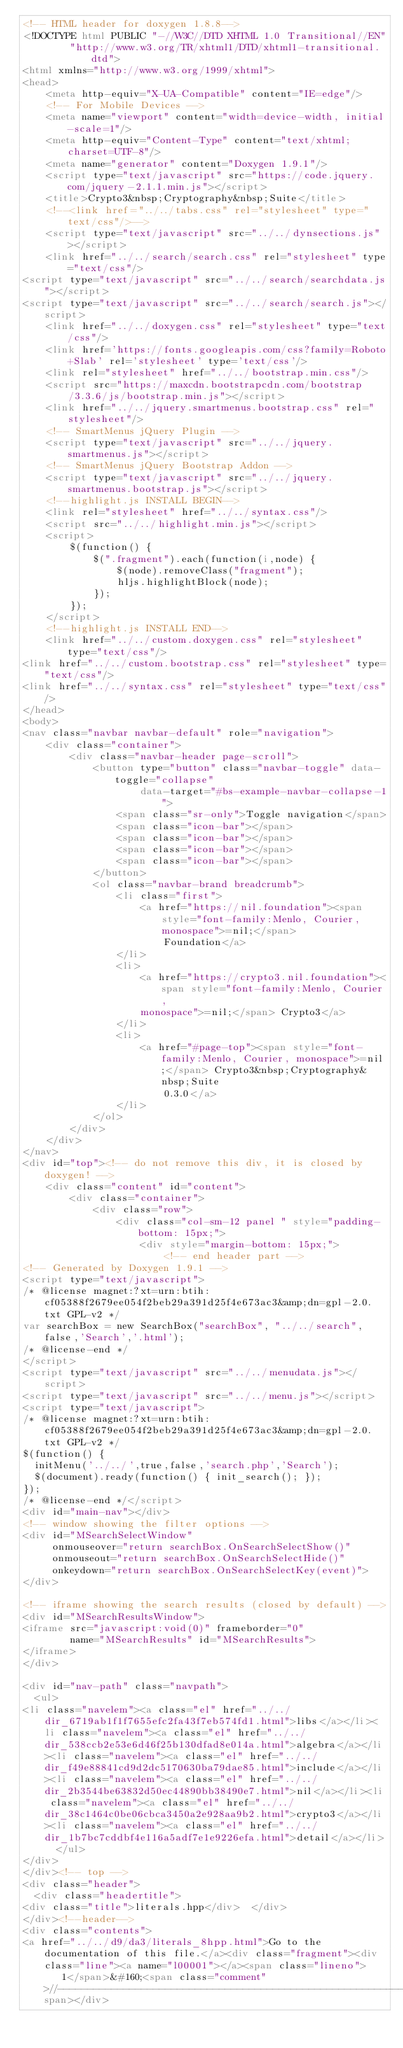Convert code to text. <code><loc_0><loc_0><loc_500><loc_500><_HTML_><!-- HTML header for doxygen 1.8.8-->
<!DOCTYPE html PUBLIC "-//W3C//DTD XHTML 1.0 Transitional//EN"
        "http://www.w3.org/TR/xhtml1/DTD/xhtml1-transitional.dtd">
<html xmlns="http://www.w3.org/1999/xhtml">
<head>
    <meta http-equiv="X-UA-Compatible" content="IE=edge"/>
    <!-- For Mobile Devices -->
    <meta name="viewport" content="width=device-width, initial-scale=1"/>
    <meta http-equiv="Content-Type" content="text/xhtml;charset=UTF-8"/>
    <meta name="generator" content="Doxygen 1.9.1"/>
    <script type="text/javascript" src="https://code.jquery.com/jquery-2.1.1.min.js"></script>
    <title>Crypto3&nbsp;Cryptography&nbsp;Suite</title>
    <!--<link href="../../tabs.css" rel="stylesheet" type="text/css"/>-->
    <script type="text/javascript" src="../../dynsections.js"></script>
    <link href="../../search/search.css" rel="stylesheet" type="text/css"/>
<script type="text/javascript" src="../../search/searchdata.js"></script>
<script type="text/javascript" src="../../search/search.js"></script>
    <link href="../../doxygen.css" rel="stylesheet" type="text/css"/>
    <link href='https://fonts.googleapis.com/css?family=Roboto+Slab' rel='stylesheet' type='text/css'/>
    <link rel="stylesheet" href="../../bootstrap.min.css"/>
    <script src="https://maxcdn.bootstrapcdn.com/bootstrap/3.3.6/js/bootstrap.min.js"></script>
    <link href="../../jquery.smartmenus.bootstrap.css" rel="stylesheet"/>
    <!-- SmartMenus jQuery Plugin -->
    <script type="text/javascript" src="../../jquery.smartmenus.js"></script>
    <!-- SmartMenus jQuery Bootstrap Addon -->
    <script type="text/javascript" src="../../jquery.smartmenus.bootstrap.js"></script>
    <!--highlight.js INSTALL BEGIN-->
    <link rel="stylesheet" href="../../syntax.css"/>
    <script src="../../highlight.min.js"></script>
    <script>
        $(function() {
            $(".fragment").each(function(i,node) {
                $(node).removeClass("fragment");
                hljs.highlightBlock(node);
            });
        });
    </script>
    <!--highlight.js INSTALL END-->
    <link href="../../custom.doxygen.css" rel="stylesheet" type="text/css"/>
<link href="../../custom.bootstrap.css" rel="stylesheet" type="text/css"/>
<link href="../../syntax.css" rel="stylesheet" type="text/css"/>
</head>
<body>
<nav class="navbar navbar-default" role="navigation">
    <div class="container">
        <div class="navbar-header page-scroll">
            <button type="button" class="navbar-toggle" data-toggle="collapse"
                    data-target="#bs-example-navbar-collapse-1">
                <span class="sr-only">Toggle navigation</span>
                <span class="icon-bar"></span>
                <span class="icon-bar"></span>
                <span class="icon-bar"></span>
                <span class="icon-bar"></span>
            </button>
            <ol class="navbar-brand breadcrumb">
                <li class="first">
                    <a href="https://nil.foundation"><span style="font-family:Menlo, Courier, monospace">=nil;</span>
                        Foundation</a>
                </li>
                <li>
                    <a href="https://crypto3.nil.foundation"><span style="font-family:Menlo, Courier,
                    monospace">=nil;</span> Crypto3</a>
                </li>
                <li>
                    <a href="#page-top"><span style="font-family:Menlo, Courier, monospace">=nil;</span> Crypto3&nbsp;Cryptography&nbsp;Suite
                        0.3.0</a>
                </li>
            </ol>
        </div>
    </div>
</nav>
<div id="top"><!-- do not remove this div, it is closed by doxygen! -->
    <div class="content" id="content">
        <div class="container">
            <div class="row">
                <div class="col-sm-12 panel " style="padding-bottom: 15px;">
                    <div style="margin-bottom: 15px;">
                        <!-- end header part -->
<!-- Generated by Doxygen 1.9.1 -->
<script type="text/javascript">
/* @license magnet:?xt=urn:btih:cf05388f2679ee054f2beb29a391d25f4e673ac3&amp;dn=gpl-2.0.txt GPL-v2 */
var searchBox = new SearchBox("searchBox", "../../search",false,'Search','.html');
/* @license-end */
</script>
<script type="text/javascript" src="../../menudata.js"></script>
<script type="text/javascript" src="../../menu.js"></script>
<script type="text/javascript">
/* @license magnet:?xt=urn:btih:cf05388f2679ee054f2beb29a391d25f4e673ac3&amp;dn=gpl-2.0.txt GPL-v2 */
$(function() {
  initMenu('../../',true,false,'search.php','Search');
  $(document).ready(function() { init_search(); });
});
/* @license-end */</script>
<div id="main-nav"></div>
<!-- window showing the filter options -->
<div id="MSearchSelectWindow"
     onmouseover="return searchBox.OnSearchSelectShow()"
     onmouseout="return searchBox.OnSearchSelectHide()"
     onkeydown="return searchBox.OnSearchSelectKey(event)">
</div>

<!-- iframe showing the search results (closed by default) -->
<div id="MSearchResultsWindow">
<iframe src="javascript:void(0)" frameborder="0" 
        name="MSearchResults" id="MSearchResults">
</iframe>
</div>

<div id="nav-path" class="navpath">
  <ul>
<li class="navelem"><a class="el" href="../../dir_6719ab1f1f7655efc2fa43f7eb574fd1.html">libs</a></li><li class="navelem"><a class="el" href="../../dir_538ccb2e53e6d46f25b130dfad8e014a.html">algebra</a></li><li class="navelem"><a class="el" href="../../dir_f49e88841cd9d2dc5170630ba79dae85.html">include</a></li><li class="navelem"><a class="el" href="../../dir_2b3544be63832d50ec44890bb38490e7.html">nil</a></li><li class="navelem"><a class="el" href="../../dir_38c1464c0be06cbca3450a2e928aa9b2.html">crypto3</a></li><li class="navelem"><a class="el" href="../../dir_1b7bc7cddbf4e116a5adf7e1e9226efa.html">detail</a></li>  </ul>
</div>
</div><!-- top -->
<div class="header">
  <div class="headertitle">
<div class="title">literals.hpp</div>  </div>
</div><!--header-->
<div class="contents">
<a href="../../d9/da3/literals_8hpp.html">Go to the documentation of this file.</a><div class="fragment"><div class="line"><a name="l00001"></a><span class="lineno">    1</span>&#160;<span class="comment">//---------------------------------------------------------------------------//</span></div></code> 